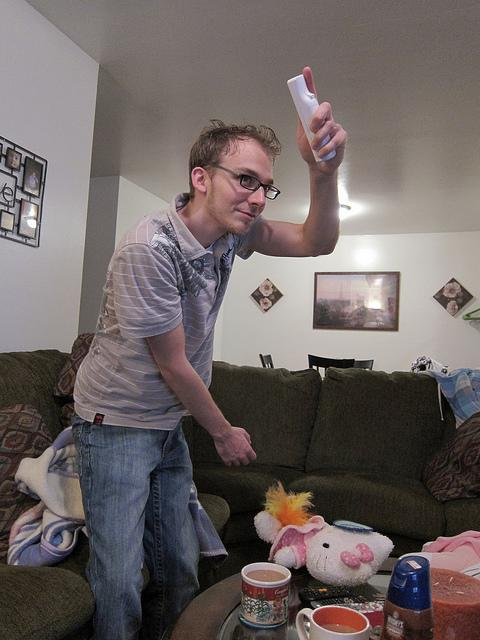What type of remote is the man holding? wii 